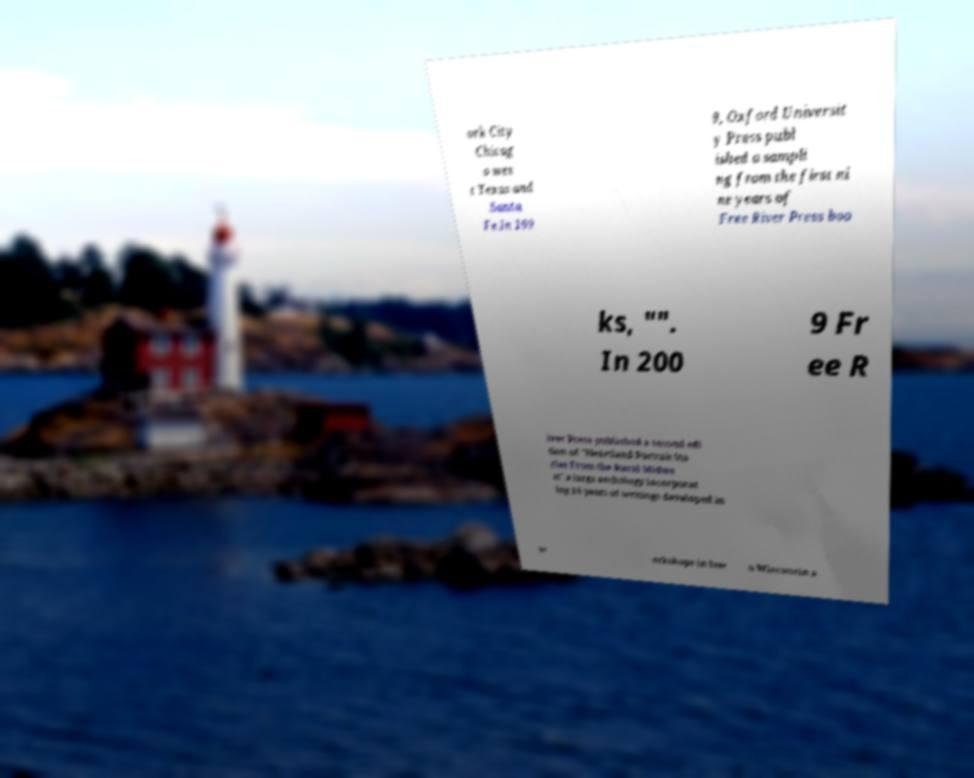There's text embedded in this image that I need extracted. Can you transcribe it verbatim? ork City Chicag o wes t Texas and Santa Fe.In 199 9, Oxford Universit y Press publ ished a sampli ng from the first ni ne years of Free River Press boo ks, "". In 200 9 Fr ee R iver Press published a second edi tion of "Heartland Portrait Sto ries From the Rural Midwe st" a large anthology incorporat ing 18 years of writings developed in w orkshops in Iow a Wisconsin a 